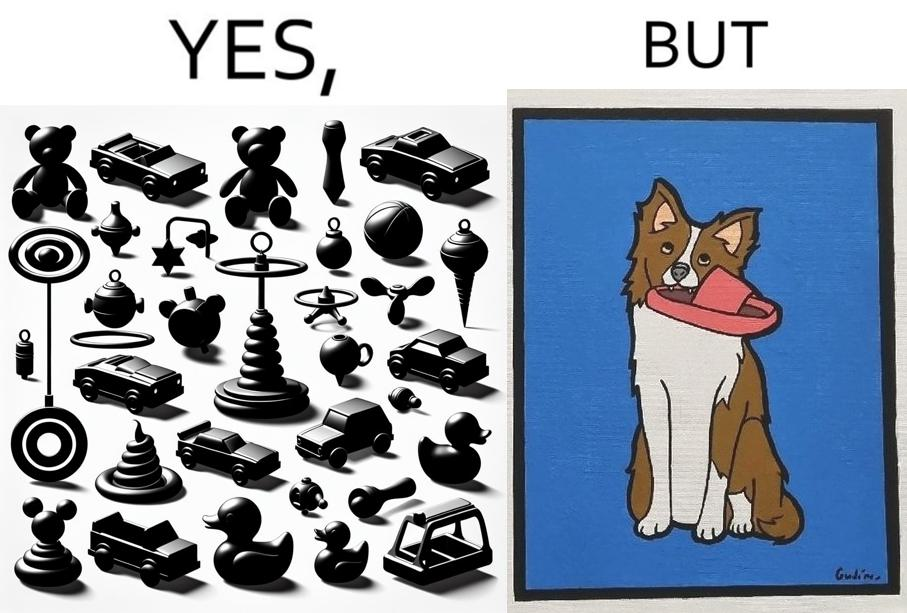Is there satirical content in this image? Yes, this image is satirical. 